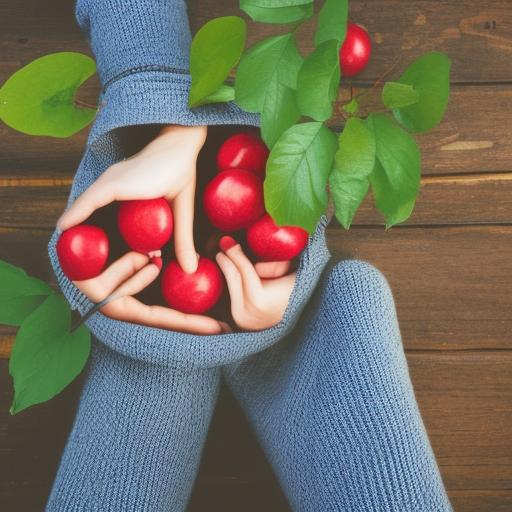What are the details of the background desktop?
A. Empty
B. Relatively rich
C. Minimal details
Answer with the option's letter from the given choices directly. The background in the image showcases a wooden surface with natural wood grain patterns which could be indicative of a desktop. It appears to be simplistic and uncluttered, providing a clean backdrop that brings focus to the subject in the foreground, suggesting option C, 'Minimal details,' might be the most accurate choice. 